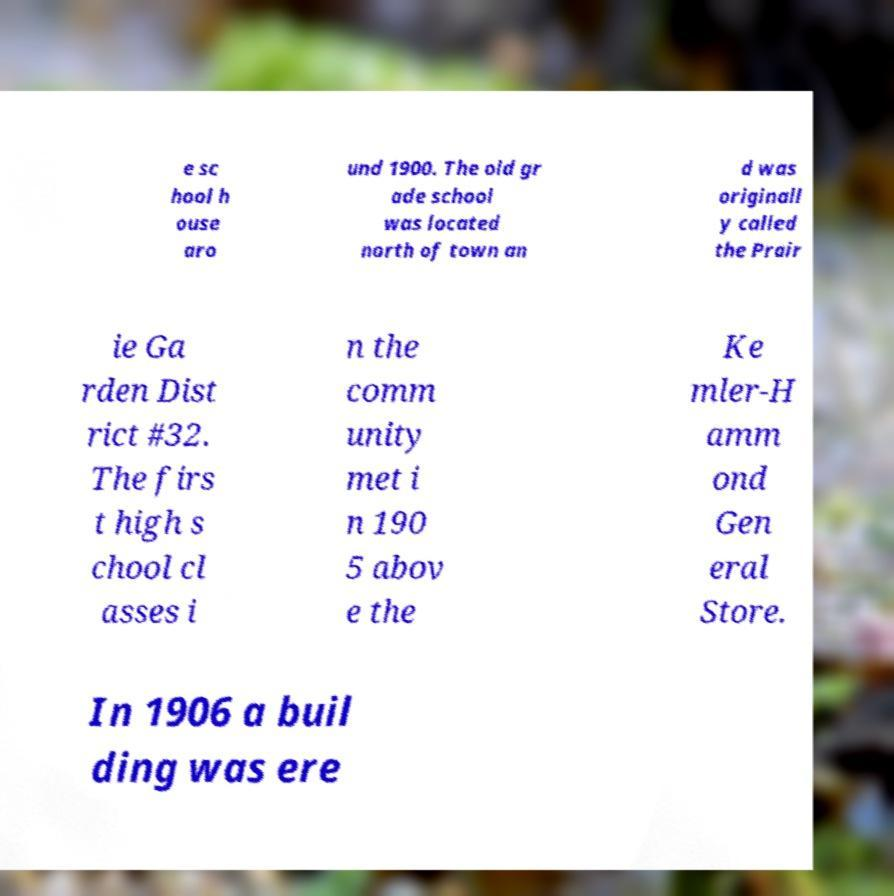Could you extract and type out the text from this image? e sc hool h ouse aro und 1900. The old gr ade school was located north of town an d was originall y called the Prair ie Ga rden Dist rict #32. The firs t high s chool cl asses i n the comm unity met i n 190 5 abov e the Ke mler-H amm ond Gen eral Store. In 1906 a buil ding was ere 